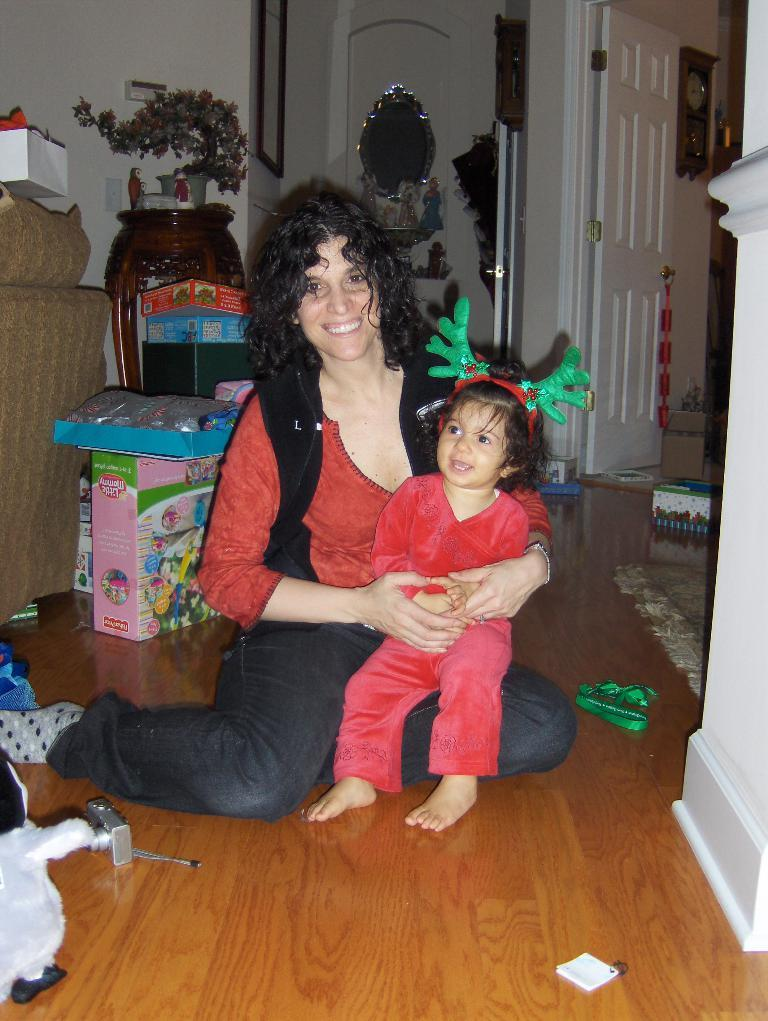Who is present in the image? There is a woman and a child in the image. What are they doing in the image? Both the woman and the child are sitting on the floor. What can be seen in the background of the image? There are doors, a clock, wall hangings, flower pots, cartons, a camera, and a carpet in the background of the image. What type of muscle is being exercised by the child in the image? There is no indication in the image that the child is exercising any muscles; they are simply sitting on the floor. 